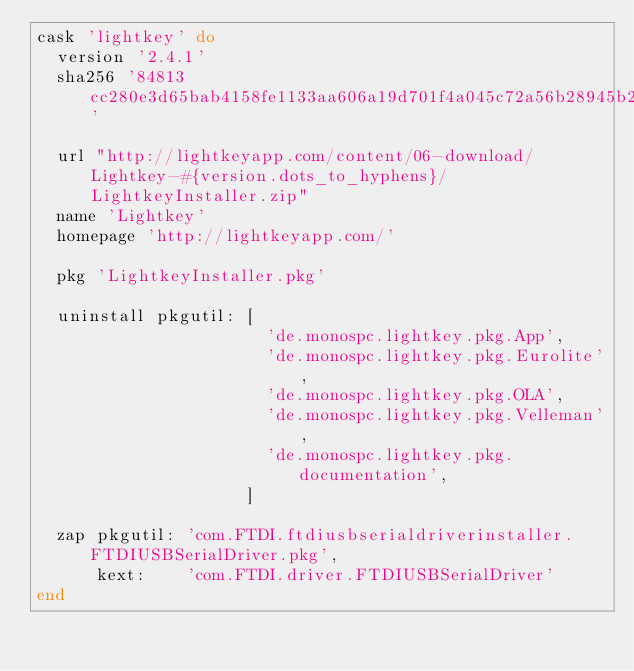<code> <loc_0><loc_0><loc_500><loc_500><_Ruby_>cask 'lightkey' do
  version '2.4.1'
  sha256 '84813cc280e3d65bab4158fe1133aa606a19d701f4a045c72a56b28945b209ae'

  url "http://lightkeyapp.com/content/06-download/Lightkey-#{version.dots_to_hyphens}/LightkeyInstaller.zip"
  name 'Lightkey'
  homepage 'http://lightkeyapp.com/'

  pkg 'LightkeyInstaller.pkg'

  uninstall pkgutil: [
                       'de.monospc.lightkey.pkg.App',
                       'de.monospc.lightkey.pkg.Eurolite',
                       'de.monospc.lightkey.pkg.OLA',
                       'de.monospc.lightkey.pkg.Velleman',
                       'de.monospc.lightkey.pkg.documentation',
                     ]

  zap pkgutil: 'com.FTDI.ftdiusbserialdriverinstaller.FTDIUSBSerialDriver.pkg',
      kext:    'com.FTDI.driver.FTDIUSBSerialDriver'
end
</code> 